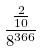Convert formula to latex. <formula><loc_0><loc_0><loc_500><loc_500>\frac { \frac { 2 } { 1 0 } } { 8 ^ { 3 6 6 } }</formula> 